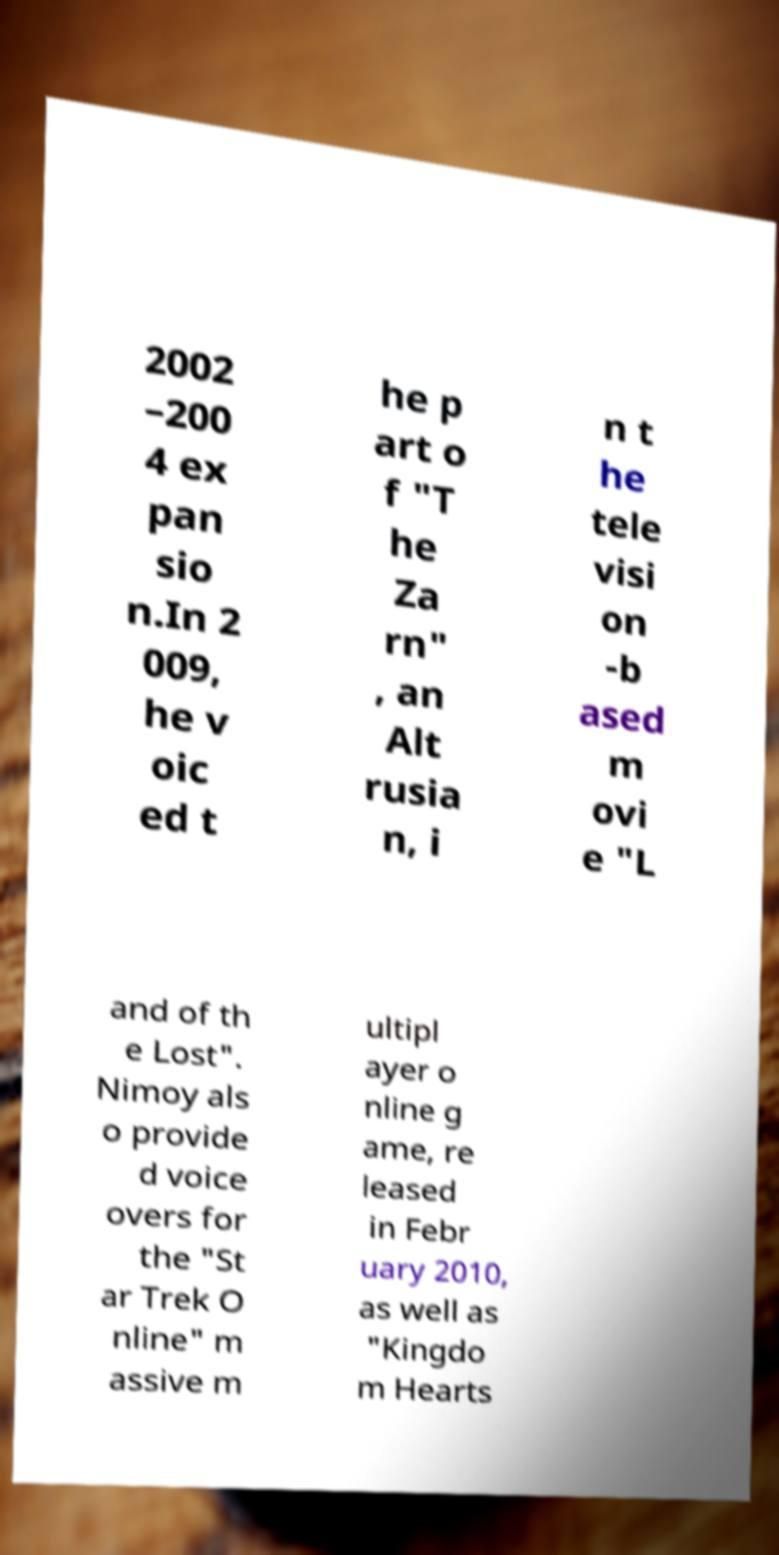Please read and relay the text visible in this image. What does it say? 2002 –200 4 ex pan sio n.In 2 009, he v oic ed t he p art o f "T he Za rn" , an Alt rusia n, i n t he tele visi on -b ased m ovi e "L and of th e Lost". Nimoy als o provide d voice overs for the "St ar Trek O nline" m assive m ultipl ayer o nline g ame, re leased in Febr uary 2010, as well as "Kingdo m Hearts 